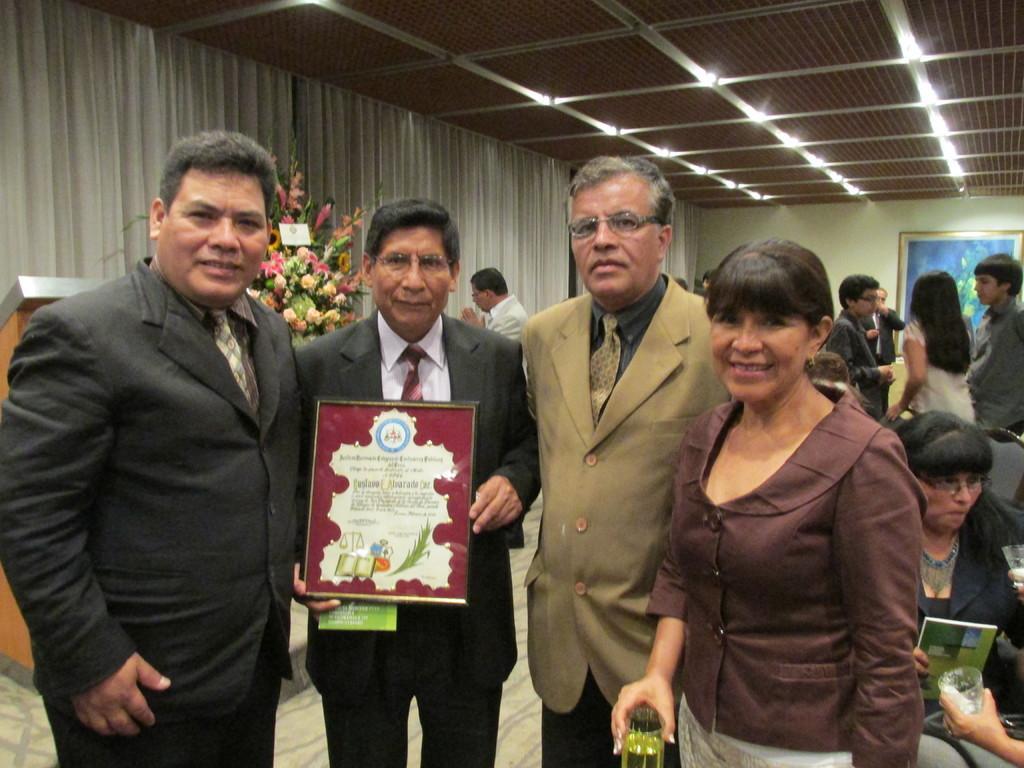Could you give a brief overview of what you see in this image? In this image there are four persons standing at left side of this image and the second person from left is holding an object. There is one person standing in middle of this image is wearing white color shirt. There are some persons standing at right side of this image and there is one woman sitting at bottom right corner of this image and there is a wall at right side of this image and there are some curtains in the background and there are some lights arranged as we can see at top of this image. 